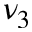<formula> <loc_0><loc_0><loc_500><loc_500>\nu _ { 3 }</formula> 